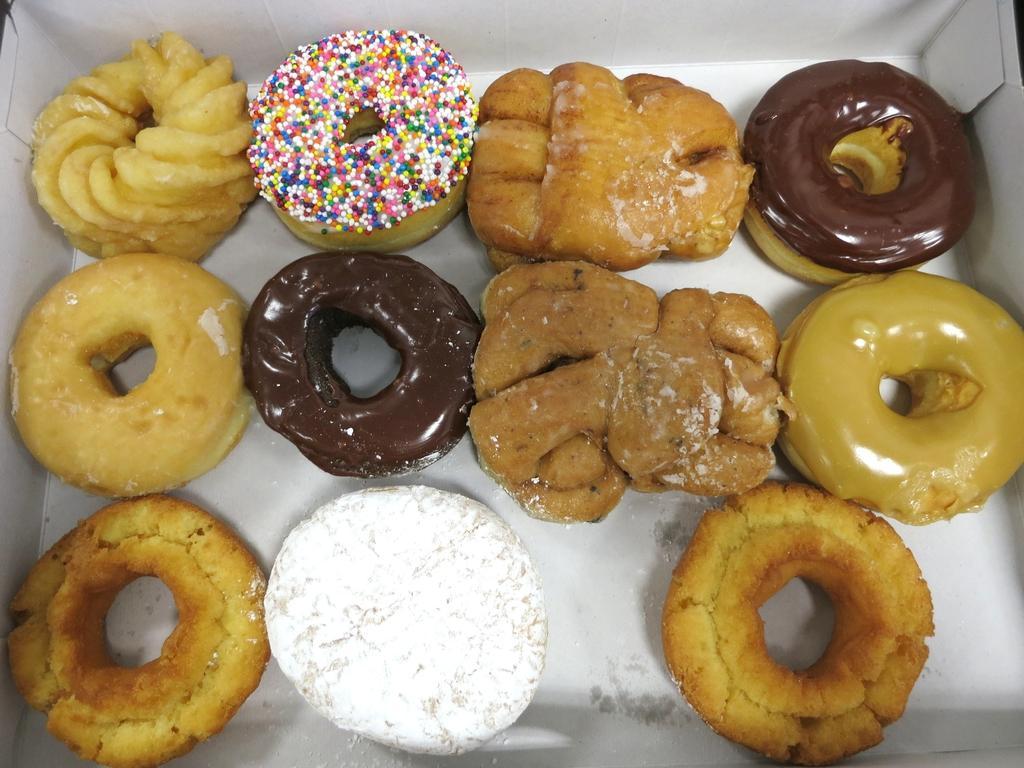In one or two sentences, can you explain what this image depicts? In this image we can see group of donuts placed in a box. 